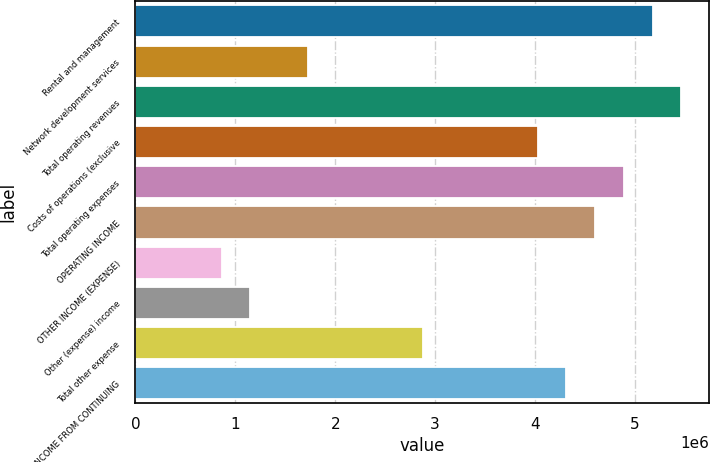Convert chart to OTSL. <chart><loc_0><loc_0><loc_500><loc_500><bar_chart><fcel>Rental and management<fcel>Network development services<fcel>Total operating revenues<fcel>Costs of operations (exclusive<fcel>Total operating expenses<fcel>OPERATING INCOME<fcel>OTHER INCOME (EXPENSE)<fcel>Other (expense) income<fcel>Total other expense<fcel>INCOME FROM CONTINUING<nl><fcel>5.17673e+06<fcel>1.72558e+06<fcel>5.46432e+06<fcel>4.02634e+06<fcel>4.88913e+06<fcel>4.60154e+06<fcel>862789<fcel>1.15038e+06<fcel>2.87596e+06<fcel>4.31394e+06<nl></chart> 